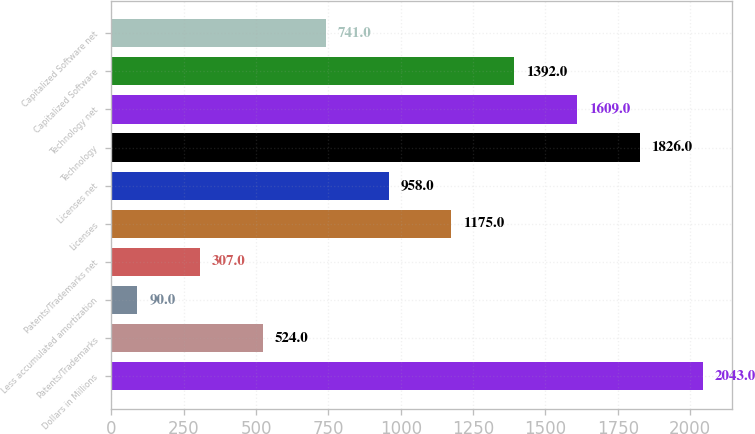Convert chart. <chart><loc_0><loc_0><loc_500><loc_500><bar_chart><fcel>Dollars in Millions<fcel>Patents/Trademarks<fcel>Less accumulated amortization<fcel>Patents/Trademarks net<fcel>Licenses<fcel>Licenses net<fcel>Technology<fcel>Technology net<fcel>Capitalized Software<fcel>Capitalized Software net<nl><fcel>2043<fcel>524<fcel>90<fcel>307<fcel>1175<fcel>958<fcel>1826<fcel>1609<fcel>1392<fcel>741<nl></chart> 